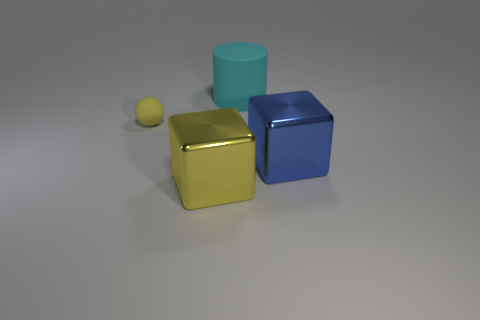Can you deduce the time of day in this scene? Given that the scene is a controlled environment with artificial lighting and a neutral background, there's no direct indication or element that reveals the time of day. The light source appears to be artificial, typically used in a photography or 3D rendering studio, which allows for any time of day simulation independent of natural sunlight. 